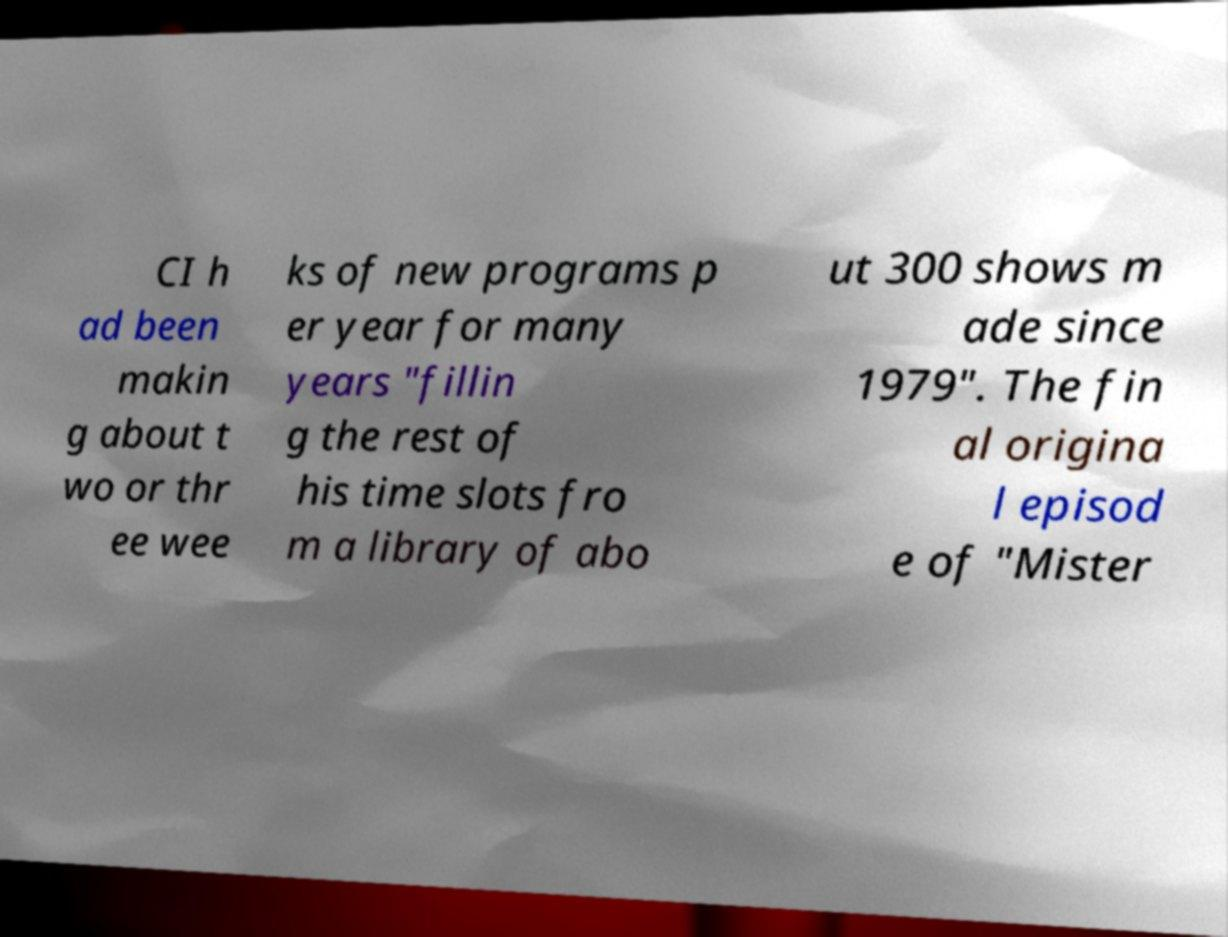Please identify and transcribe the text found in this image. CI h ad been makin g about t wo or thr ee wee ks of new programs p er year for many years "fillin g the rest of his time slots fro m a library of abo ut 300 shows m ade since 1979". The fin al origina l episod e of "Mister 